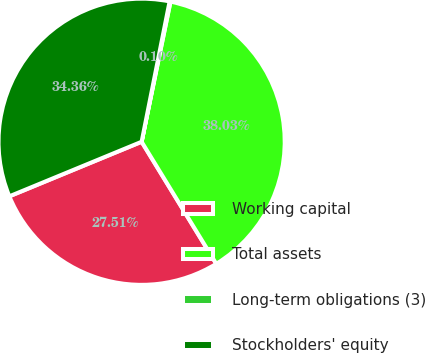<chart> <loc_0><loc_0><loc_500><loc_500><pie_chart><fcel>Working capital<fcel>Total assets<fcel>Long-term obligations (3)<fcel>Stockholders' equity<nl><fcel>27.51%<fcel>38.03%<fcel>0.1%<fcel>34.36%<nl></chart> 